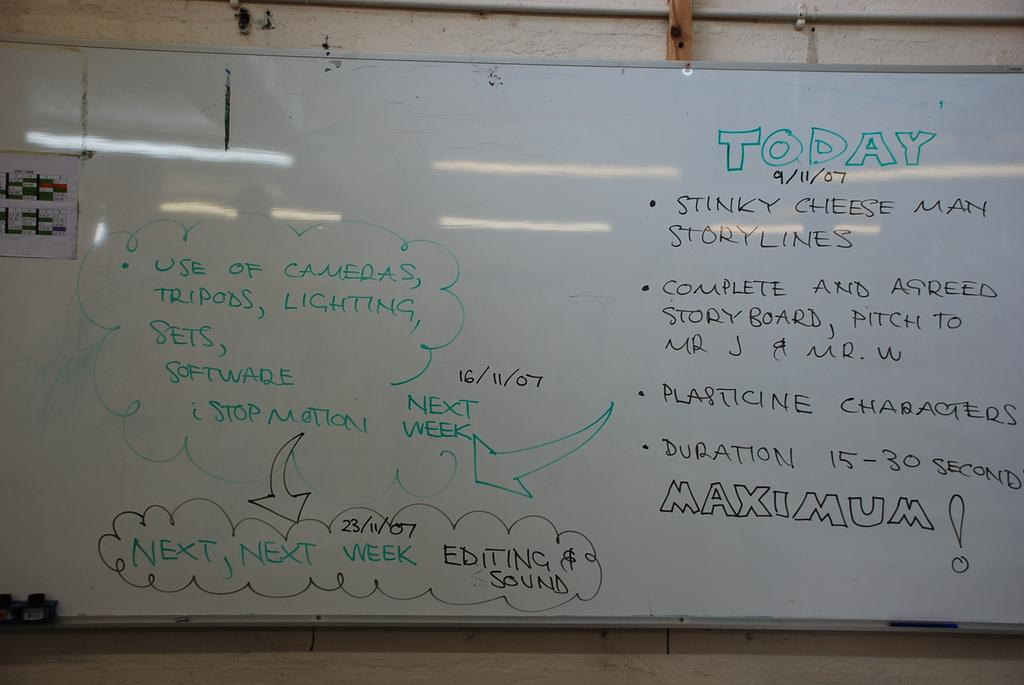<image>
Describe the image concisely. A whiteboard with notes that include info on cameras, tripods, and lighting 